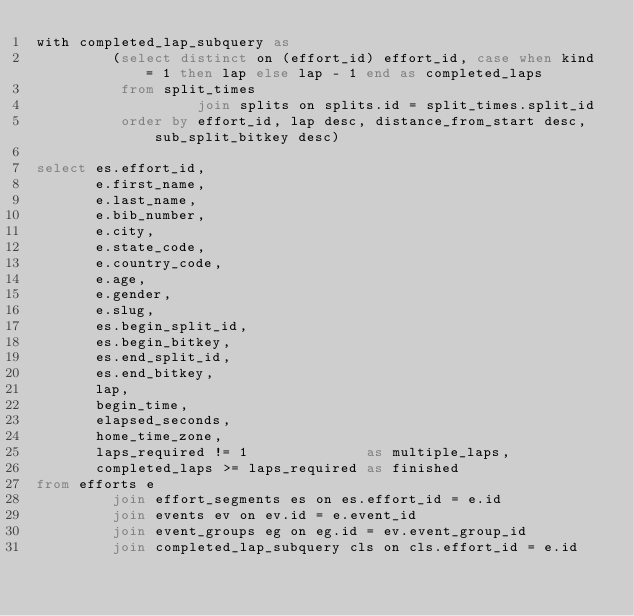<code> <loc_0><loc_0><loc_500><loc_500><_SQL_>with completed_lap_subquery as
         (select distinct on (effort_id) effort_id, case when kind = 1 then lap else lap - 1 end as completed_laps
          from split_times
                   join splits on splits.id = split_times.split_id
          order by effort_id, lap desc, distance_from_start desc, sub_split_bitkey desc)

select es.effort_id,
       e.first_name,
       e.last_name,
       e.bib_number,
       e.city,
       e.state_code,
       e.country_code,
       e.age,
       e.gender,
       e.slug,
       es.begin_split_id,
       es.begin_bitkey,
       es.end_split_id,
       es.end_bitkey,
       lap,
       begin_time,
       elapsed_seconds,
       home_time_zone,
       laps_required != 1              as multiple_laps,
       completed_laps >= laps_required as finished
from efforts e
         join effort_segments es on es.effort_id = e.id
         join events ev on ev.id = e.event_id
         join event_groups eg on eg.id = ev.event_group_id
         join completed_lap_subquery cls on cls.effort_id = e.id
</code> 